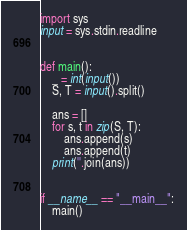Convert code to text. <code><loc_0><loc_0><loc_500><loc_500><_Python_>import sys
input = sys.stdin.readline


def main():
    _ = int(input())
    S, T = input().split()

    ans = []
    for s, t in zip(S, T):
        ans.append(s)
        ans.append(t)
    print(''.join(ans))


if __name__ == "__main__":
    main()
</code> 